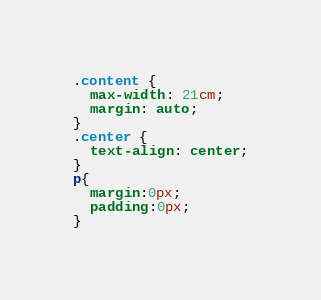<code> <loc_0><loc_0><loc_500><loc_500><_CSS_>
.content {
  max-width: 21cm;
  margin: auto;
}
.center {
  text-align: center;
}
p{
  margin:0px;
  padding:0px;
}</code> 